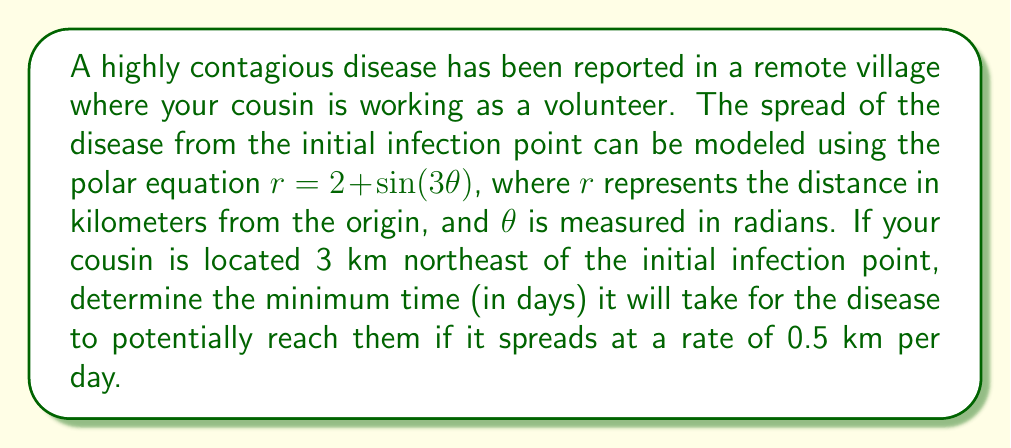Teach me how to tackle this problem. To solve this problem, we need to follow these steps:

1) First, we need to determine the maximum radius of the polar curve, as this will represent the furthest reach of the disease.

   The equation is $r = 2 + \sin(3\theta)$
   The maximum value of sine is 1, so the maximum radius is:
   $r_{max} = 2 + 1 = 3$ km

2) Next, we need to find the position of the cousin in polar coordinates.
   Northeast direction corresponds to $\theta = \frac{\pi}{4}$ radians
   The distance is given as 3 km

   So, in polar coordinates, the cousin's position is $(3, \frac{\pi}{4})$

3) Now, we need to check if the disease will reach the cousin's position.
   At $\theta = \frac{\pi}{4}$, the radius of the disease spread is:
   
   $r = 2 + \sin(3 \cdot \frac{\pi}{4}) = 2 + \sin(\frac{3\pi}{4}) = 2 + \frac{\sqrt{2}}{2} \approx 2.71$ km

4) Since 2.71 km < 3 km, the disease will not directly reach the cousin's position.

5) However, we need to calculate how long it will take for the disease to spread to its maximum radius of 3 km.

   Time = Distance / Rate
   $t = \frac{3 \text{ km} - 2 \text{ km}}{0.5 \text{ km/day}} = \frac{1 \text{ km}}{0.5 \text{ km/day}} = 2 \text{ days}$

Therefore, it will take a minimum of 2 days for the disease to potentially reach the cousin's location.
Answer: 2 days 